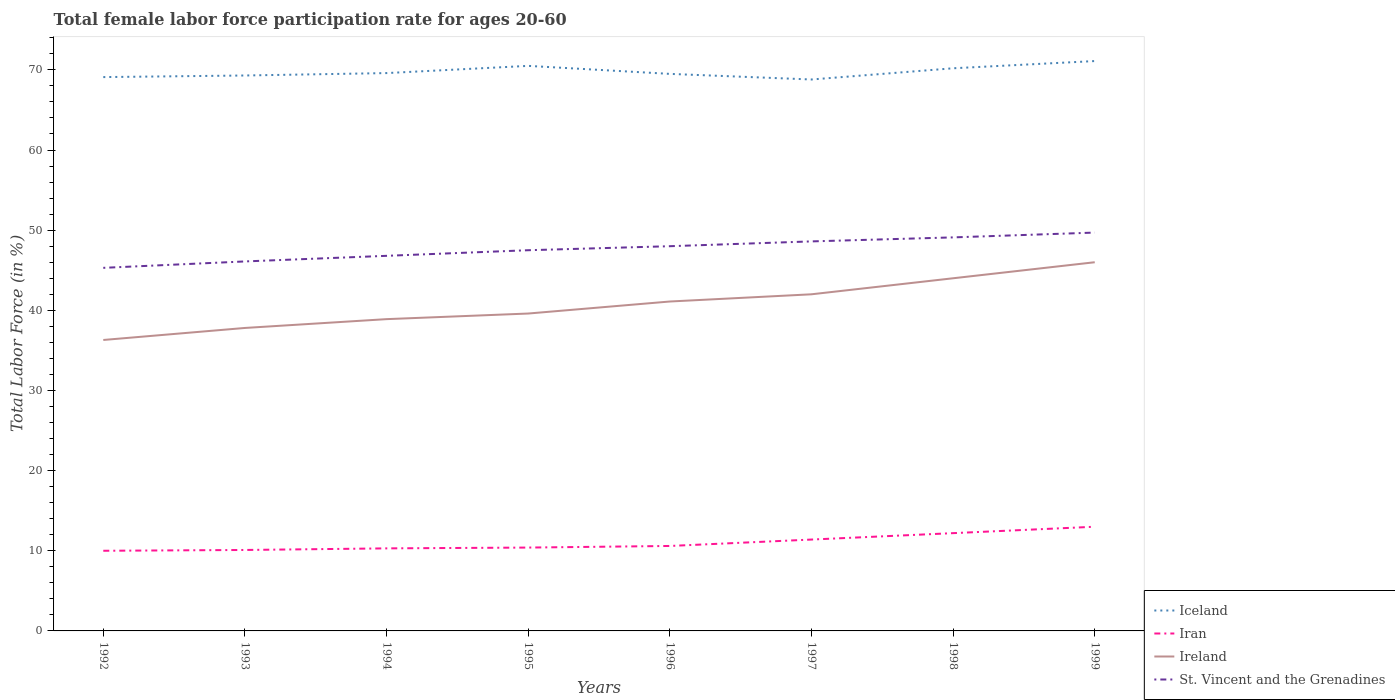Does the line corresponding to Iran intersect with the line corresponding to Ireland?
Offer a terse response. No. Is the number of lines equal to the number of legend labels?
Keep it short and to the point. Yes. Across all years, what is the maximum female labor force participation rate in Ireland?
Keep it short and to the point. 36.3. In which year was the female labor force participation rate in Iran maximum?
Offer a terse response. 1992. What is the total female labor force participation rate in St. Vincent and the Grenadines in the graph?
Ensure brevity in your answer.  -3.3. What is the difference between the highest and the second highest female labor force participation rate in Iran?
Give a very brief answer. 3. Is the female labor force participation rate in St. Vincent and the Grenadines strictly greater than the female labor force participation rate in Iceland over the years?
Provide a short and direct response. Yes. How many lines are there?
Provide a succinct answer. 4. What is the difference between two consecutive major ticks on the Y-axis?
Keep it short and to the point. 10. Are the values on the major ticks of Y-axis written in scientific E-notation?
Provide a succinct answer. No. Does the graph contain any zero values?
Your response must be concise. No. Does the graph contain grids?
Your response must be concise. No. How are the legend labels stacked?
Make the answer very short. Vertical. What is the title of the graph?
Provide a short and direct response. Total female labor force participation rate for ages 20-60. Does "St. Kitts and Nevis" appear as one of the legend labels in the graph?
Offer a very short reply. No. What is the Total Labor Force (in %) in Iceland in 1992?
Provide a succinct answer. 69.1. What is the Total Labor Force (in %) of Iran in 1992?
Offer a very short reply. 10. What is the Total Labor Force (in %) in Ireland in 1992?
Your response must be concise. 36.3. What is the Total Labor Force (in %) of St. Vincent and the Grenadines in 1992?
Provide a succinct answer. 45.3. What is the Total Labor Force (in %) in Iceland in 1993?
Make the answer very short. 69.3. What is the Total Labor Force (in %) in Iran in 1993?
Give a very brief answer. 10.1. What is the Total Labor Force (in %) in Ireland in 1993?
Keep it short and to the point. 37.8. What is the Total Labor Force (in %) in St. Vincent and the Grenadines in 1993?
Keep it short and to the point. 46.1. What is the Total Labor Force (in %) in Iceland in 1994?
Keep it short and to the point. 69.6. What is the Total Labor Force (in %) of Iran in 1994?
Your answer should be very brief. 10.3. What is the Total Labor Force (in %) of Ireland in 1994?
Ensure brevity in your answer.  38.9. What is the Total Labor Force (in %) of St. Vincent and the Grenadines in 1994?
Offer a very short reply. 46.8. What is the Total Labor Force (in %) of Iceland in 1995?
Give a very brief answer. 70.5. What is the Total Labor Force (in %) in Iran in 1995?
Ensure brevity in your answer.  10.4. What is the Total Labor Force (in %) in Ireland in 1995?
Provide a short and direct response. 39.6. What is the Total Labor Force (in %) of St. Vincent and the Grenadines in 1995?
Provide a succinct answer. 47.5. What is the Total Labor Force (in %) in Iceland in 1996?
Make the answer very short. 69.5. What is the Total Labor Force (in %) in Iran in 1996?
Provide a short and direct response. 10.6. What is the Total Labor Force (in %) of Ireland in 1996?
Give a very brief answer. 41.1. What is the Total Labor Force (in %) in Iceland in 1997?
Give a very brief answer. 68.8. What is the Total Labor Force (in %) of Iran in 1997?
Provide a short and direct response. 11.4. What is the Total Labor Force (in %) in St. Vincent and the Grenadines in 1997?
Keep it short and to the point. 48.6. What is the Total Labor Force (in %) of Iceland in 1998?
Provide a succinct answer. 70.2. What is the Total Labor Force (in %) in Iran in 1998?
Your answer should be very brief. 12.2. What is the Total Labor Force (in %) in Ireland in 1998?
Give a very brief answer. 44. What is the Total Labor Force (in %) in St. Vincent and the Grenadines in 1998?
Offer a terse response. 49.1. What is the Total Labor Force (in %) of Iceland in 1999?
Provide a succinct answer. 71.1. What is the Total Labor Force (in %) in St. Vincent and the Grenadines in 1999?
Offer a very short reply. 49.7. Across all years, what is the maximum Total Labor Force (in %) of Iceland?
Offer a very short reply. 71.1. Across all years, what is the maximum Total Labor Force (in %) in St. Vincent and the Grenadines?
Provide a short and direct response. 49.7. Across all years, what is the minimum Total Labor Force (in %) of Iceland?
Offer a very short reply. 68.8. Across all years, what is the minimum Total Labor Force (in %) in Ireland?
Offer a very short reply. 36.3. Across all years, what is the minimum Total Labor Force (in %) of St. Vincent and the Grenadines?
Your answer should be compact. 45.3. What is the total Total Labor Force (in %) of Iceland in the graph?
Ensure brevity in your answer.  558.1. What is the total Total Labor Force (in %) in Ireland in the graph?
Offer a terse response. 325.7. What is the total Total Labor Force (in %) in St. Vincent and the Grenadines in the graph?
Your answer should be very brief. 381.1. What is the difference between the Total Labor Force (in %) of Ireland in 1992 and that in 1993?
Your response must be concise. -1.5. What is the difference between the Total Labor Force (in %) in St. Vincent and the Grenadines in 1992 and that in 1993?
Provide a succinct answer. -0.8. What is the difference between the Total Labor Force (in %) of Iceland in 1992 and that in 1994?
Offer a very short reply. -0.5. What is the difference between the Total Labor Force (in %) in St. Vincent and the Grenadines in 1992 and that in 1994?
Your response must be concise. -1.5. What is the difference between the Total Labor Force (in %) of Iceland in 1992 and that in 1995?
Offer a terse response. -1.4. What is the difference between the Total Labor Force (in %) of Ireland in 1992 and that in 1995?
Make the answer very short. -3.3. What is the difference between the Total Labor Force (in %) in St. Vincent and the Grenadines in 1992 and that in 1995?
Provide a short and direct response. -2.2. What is the difference between the Total Labor Force (in %) of Iceland in 1992 and that in 1996?
Make the answer very short. -0.4. What is the difference between the Total Labor Force (in %) in Iran in 1992 and that in 1996?
Offer a very short reply. -0.6. What is the difference between the Total Labor Force (in %) of Ireland in 1992 and that in 1996?
Offer a terse response. -4.8. What is the difference between the Total Labor Force (in %) of Iceland in 1992 and that in 1997?
Make the answer very short. 0.3. What is the difference between the Total Labor Force (in %) in Iran in 1992 and that in 1997?
Keep it short and to the point. -1.4. What is the difference between the Total Labor Force (in %) in Ireland in 1992 and that in 1997?
Ensure brevity in your answer.  -5.7. What is the difference between the Total Labor Force (in %) in Iran in 1992 and that in 1999?
Offer a terse response. -3. What is the difference between the Total Labor Force (in %) of Iceland in 1993 and that in 1995?
Offer a very short reply. -1.2. What is the difference between the Total Labor Force (in %) in Iran in 1993 and that in 1995?
Your answer should be compact. -0.3. What is the difference between the Total Labor Force (in %) in Ireland in 1993 and that in 1995?
Provide a short and direct response. -1.8. What is the difference between the Total Labor Force (in %) of Iceland in 1993 and that in 1996?
Your answer should be compact. -0.2. What is the difference between the Total Labor Force (in %) of Iran in 1993 and that in 1996?
Your answer should be very brief. -0.5. What is the difference between the Total Labor Force (in %) of Iceland in 1993 and that in 1997?
Make the answer very short. 0.5. What is the difference between the Total Labor Force (in %) in Iran in 1993 and that in 1997?
Offer a very short reply. -1.3. What is the difference between the Total Labor Force (in %) of Ireland in 1993 and that in 1997?
Make the answer very short. -4.2. What is the difference between the Total Labor Force (in %) in St. Vincent and the Grenadines in 1993 and that in 1997?
Give a very brief answer. -2.5. What is the difference between the Total Labor Force (in %) in Iceland in 1993 and that in 1998?
Provide a short and direct response. -0.9. What is the difference between the Total Labor Force (in %) of Ireland in 1994 and that in 1995?
Your response must be concise. -0.7. What is the difference between the Total Labor Force (in %) of Iceland in 1994 and that in 1996?
Offer a very short reply. 0.1. What is the difference between the Total Labor Force (in %) of Ireland in 1994 and that in 1996?
Keep it short and to the point. -2.2. What is the difference between the Total Labor Force (in %) in Iran in 1994 and that in 1998?
Offer a terse response. -1.9. What is the difference between the Total Labor Force (in %) of Iceland in 1994 and that in 1999?
Make the answer very short. -1.5. What is the difference between the Total Labor Force (in %) of Iran in 1994 and that in 1999?
Make the answer very short. -2.7. What is the difference between the Total Labor Force (in %) of Ireland in 1994 and that in 1999?
Offer a very short reply. -7.1. What is the difference between the Total Labor Force (in %) in St. Vincent and the Grenadines in 1994 and that in 1999?
Offer a terse response. -2.9. What is the difference between the Total Labor Force (in %) in Iran in 1995 and that in 1996?
Provide a succinct answer. -0.2. What is the difference between the Total Labor Force (in %) of Iran in 1995 and that in 1997?
Make the answer very short. -1. What is the difference between the Total Labor Force (in %) of Ireland in 1995 and that in 1997?
Offer a very short reply. -2.4. What is the difference between the Total Labor Force (in %) in St. Vincent and the Grenadines in 1995 and that in 1997?
Your answer should be very brief. -1.1. What is the difference between the Total Labor Force (in %) in Iceland in 1995 and that in 1998?
Offer a very short reply. 0.3. What is the difference between the Total Labor Force (in %) of Iran in 1995 and that in 1998?
Your answer should be very brief. -1.8. What is the difference between the Total Labor Force (in %) in Ireland in 1995 and that in 1998?
Make the answer very short. -4.4. What is the difference between the Total Labor Force (in %) in St. Vincent and the Grenadines in 1995 and that in 1998?
Make the answer very short. -1.6. What is the difference between the Total Labor Force (in %) of Iran in 1995 and that in 1999?
Provide a short and direct response. -2.6. What is the difference between the Total Labor Force (in %) of Iran in 1996 and that in 1997?
Your answer should be very brief. -0.8. What is the difference between the Total Labor Force (in %) in Ireland in 1996 and that in 1997?
Offer a terse response. -0.9. What is the difference between the Total Labor Force (in %) of Iceland in 1996 and that in 1998?
Make the answer very short. -0.7. What is the difference between the Total Labor Force (in %) in Iran in 1996 and that in 1998?
Offer a very short reply. -1.6. What is the difference between the Total Labor Force (in %) in St. Vincent and the Grenadines in 1996 and that in 1998?
Provide a succinct answer. -1.1. What is the difference between the Total Labor Force (in %) of Ireland in 1996 and that in 1999?
Ensure brevity in your answer.  -4.9. What is the difference between the Total Labor Force (in %) in St. Vincent and the Grenadines in 1996 and that in 1999?
Make the answer very short. -1.7. What is the difference between the Total Labor Force (in %) of Iran in 1997 and that in 1998?
Keep it short and to the point. -0.8. What is the difference between the Total Labor Force (in %) in Ireland in 1997 and that in 1999?
Your answer should be compact. -4. What is the difference between the Total Labor Force (in %) in St. Vincent and the Grenadines in 1997 and that in 1999?
Your answer should be very brief. -1.1. What is the difference between the Total Labor Force (in %) in St. Vincent and the Grenadines in 1998 and that in 1999?
Provide a succinct answer. -0.6. What is the difference between the Total Labor Force (in %) of Iceland in 1992 and the Total Labor Force (in %) of Iran in 1993?
Keep it short and to the point. 59. What is the difference between the Total Labor Force (in %) of Iceland in 1992 and the Total Labor Force (in %) of Ireland in 1993?
Offer a very short reply. 31.3. What is the difference between the Total Labor Force (in %) in Iran in 1992 and the Total Labor Force (in %) in Ireland in 1993?
Provide a short and direct response. -27.8. What is the difference between the Total Labor Force (in %) in Iran in 1992 and the Total Labor Force (in %) in St. Vincent and the Grenadines in 1993?
Provide a short and direct response. -36.1. What is the difference between the Total Labor Force (in %) in Ireland in 1992 and the Total Labor Force (in %) in St. Vincent and the Grenadines in 1993?
Your answer should be very brief. -9.8. What is the difference between the Total Labor Force (in %) in Iceland in 1992 and the Total Labor Force (in %) in Iran in 1994?
Offer a terse response. 58.8. What is the difference between the Total Labor Force (in %) in Iceland in 1992 and the Total Labor Force (in %) in Ireland in 1994?
Your answer should be very brief. 30.2. What is the difference between the Total Labor Force (in %) of Iceland in 1992 and the Total Labor Force (in %) of St. Vincent and the Grenadines in 1994?
Offer a very short reply. 22.3. What is the difference between the Total Labor Force (in %) of Iran in 1992 and the Total Labor Force (in %) of Ireland in 1994?
Keep it short and to the point. -28.9. What is the difference between the Total Labor Force (in %) in Iran in 1992 and the Total Labor Force (in %) in St. Vincent and the Grenadines in 1994?
Make the answer very short. -36.8. What is the difference between the Total Labor Force (in %) of Ireland in 1992 and the Total Labor Force (in %) of St. Vincent and the Grenadines in 1994?
Ensure brevity in your answer.  -10.5. What is the difference between the Total Labor Force (in %) of Iceland in 1992 and the Total Labor Force (in %) of Iran in 1995?
Make the answer very short. 58.7. What is the difference between the Total Labor Force (in %) of Iceland in 1992 and the Total Labor Force (in %) of Ireland in 1995?
Offer a terse response. 29.5. What is the difference between the Total Labor Force (in %) in Iceland in 1992 and the Total Labor Force (in %) in St. Vincent and the Grenadines in 1995?
Your answer should be very brief. 21.6. What is the difference between the Total Labor Force (in %) in Iran in 1992 and the Total Labor Force (in %) in Ireland in 1995?
Keep it short and to the point. -29.6. What is the difference between the Total Labor Force (in %) of Iran in 1992 and the Total Labor Force (in %) of St. Vincent and the Grenadines in 1995?
Provide a short and direct response. -37.5. What is the difference between the Total Labor Force (in %) in Iceland in 1992 and the Total Labor Force (in %) in Iran in 1996?
Your answer should be very brief. 58.5. What is the difference between the Total Labor Force (in %) in Iceland in 1992 and the Total Labor Force (in %) in Ireland in 1996?
Your answer should be very brief. 28. What is the difference between the Total Labor Force (in %) in Iceland in 1992 and the Total Labor Force (in %) in St. Vincent and the Grenadines in 1996?
Give a very brief answer. 21.1. What is the difference between the Total Labor Force (in %) of Iran in 1992 and the Total Labor Force (in %) of Ireland in 1996?
Your answer should be very brief. -31.1. What is the difference between the Total Labor Force (in %) in Iran in 1992 and the Total Labor Force (in %) in St. Vincent and the Grenadines in 1996?
Provide a succinct answer. -38. What is the difference between the Total Labor Force (in %) of Ireland in 1992 and the Total Labor Force (in %) of St. Vincent and the Grenadines in 1996?
Ensure brevity in your answer.  -11.7. What is the difference between the Total Labor Force (in %) of Iceland in 1992 and the Total Labor Force (in %) of Iran in 1997?
Give a very brief answer. 57.7. What is the difference between the Total Labor Force (in %) in Iceland in 1992 and the Total Labor Force (in %) in Ireland in 1997?
Offer a terse response. 27.1. What is the difference between the Total Labor Force (in %) of Iran in 1992 and the Total Labor Force (in %) of Ireland in 1997?
Keep it short and to the point. -32. What is the difference between the Total Labor Force (in %) of Iran in 1992 and the Total Labor Force (in %) of St. Vincent and the Grenadines in 1997?
Provide a short and direct response. -38.6. What is the difference between the Total Labor Force (in %) in Ireland in 1992 and the Total Labor Force (in %) in St. Vincent and the Grenadines in 1997?
Provide a short and direct response. -12.3. What is the difference between the Total Labor Force (in %) of Iceland in 1992 and the Total Labor Force (in %) of Iran in 1998?
Offer a very short reply. 56.9. What is the difference between the Total Labor Force (in %) in Iceland in 1992 and the Total Labor Force (in %) in Ireland in 1998?
Offer a terse response. 25.1. What is the difference between the Total Labor Force (in %) in Iran in 1992 and the Total Labor Force (in %) in Ireland in 1998?
Provide a succinct answer. -34. What is the difference between the Total Labor Force (in %) of Iran in 1992 and the Total Labor Force (in %) of St. Vincent and the Grenadines in 1998?
Make the answer very short. -39.1. What is the difference between the Total Labor Force (in %) in Iceland in 1992 and the Total Labor Force (in %) in Iran in 1999?
Provide a succinct answer. 56.1. What is the difference between the Total Labor Force (in %) of Iceland in 1992 and the Total Labor Force (in %) of Ireland in 1999?
Offer a terse response. 23.1. What is the difference between the Total Labor Force (in %) in Iceland in 1992 and the Total Labor Force (in %) in St. Vincent and the Grenadines in 1999?
Ensure brevity in your answer.  19.4. What is the difference between the Total Labor Force (in %) in Iran in 1992 and the Total Labor Force (in %) in Ireland in 1999?
Your response must be concise. -36. What is the difference between the Total Labor Force (in %) in Iran in 1992 and the Total Labor Force (in %) in St. Vincent and the Grenadines in 1999?
Make the answer very short. -39.7. What is the difference between the Total Labor Force (in %) of Ireland in 1992 and the Total Labor Force (in %) of St. Vincent and the Grenadines in 1999?
Offer a terse response. -13.4. What is the difference between the Total Labor Force (in %) of Iceland in 1993 and the Total Labor Force (in %) of Ireland in 1994?
Offer a terse response. 30.4. What is the difference between the Total Labor Force (in %) in Iceland in 1993 and the Total Labor Force (in %) in St. Vincent and the Grenadines in 1994?
Ensure brevity in your answer.  22.5. What is the difference between the Total Labor Force (in %) of Iran in 1993 and the Total Labor Force (in %) of Ireland in 1994?
Provide a short and direct response. -28.8. What is the difference between the Total Labor Force (in %) of Iran in 1993 and the Total Labor Force (in %) of St. Vincent and the Grenadines in 1994?
Your answer should be very brief. -36.7. What is the difference between the Total Labor Force (in %) in Iceland in 1993 and the Total Labor Force (in %) in Iran in 1995?
Offer a terse response. 58.9. What is the difference between the Total Labor Force (in %) of Iceland in 1993 and the Total Labor Force (in %) of Ireland in 1995?
Your answer should be compact. 29.7. What is the difference between the Total Labor Force (in %) of Iceland in 1993 and the Total Labor Force (in %) of St. Vincent and the Grenadines in 1995?
Give a very brief answer. 21.8. What is the difference between the Total Labor Force (in %) of Iran in 1993 and the Total Labor Force (in %) of Ireland in 1995?
Make the answer very short. -29.5. What is the difference between the Total Labor Force (in %) of Iran in 1993 and the Total Labor Force (in %) of St. Vincent and the Grenadines in 1995?
Your answer should be very brief. -37.4. What is the difference between the Total Labor Force (in %) of Iceland in 1993 and the Total Labor Force (in %) of Iran in 1996?
Your answer should be compact. 58.7. What is the difference between the Total Labor Force (in %) of Iceland in 1993 and the Total Labor Force (in %) of Ireland in 1996?
Provide a short and direct response. 28.2. What is the difference between the Total Labor Force (in %) in Iceland in 1993 and the Total Labor Force (in %) in St. Vincent and the Grenadines in 1996?
Offer a terse response. 21.3. What is the difference between the Total Labor Force (in %) of Iran in 1993 and the Total Labor Force (in %) of Ireland in 1996?
Offer a terse response. -31. What is the difference between the Total Labor Force (in %) in Iran in 1993 and the Total Labor Force (in %) in St. Vincent and the Grenadines in 1996?
Ensure brevity in your answer.  -37.9. What is the difference between the Total Labor Force (in %) of Iceland in 1993 and the Total Labor Force (in %) of Iran in 1997?
Make the answer very short. 57.9. What is the difference between the Total Labor Force (in %) of Iceland in 1993 and the Total Labor Force (in %) of Ireland in 1997?
Your answer should be very brief. 27.3. What is the difference between the Total Labor Force (in %) in Iceland in 1993 and the Total Labor Force (in %) in St. Vincent and the Grenadines in 1997?
Your answer should be very brief. 20.7. What is the difference between the Total Labor Force (in %) in Iran in 1993 and the Total Labor Force (in %) in Ireland in 1997?
Provide a succinct answer. -31.9. What is the difference between the Total Labor Force (in %) in Iran in 1993 and the Total Labor Force (in %) in St. Vincent and the Grenadines in 1997?
Your answer should be very brief. -38.5. What is the difference between the Total Labor Force (in %) in Ireland in 1993 and the Total Labor Force (in %) in St. Vincent and the Grenadines in 1997?
Give a very brief answer. -10.8. What is the difference between the Total Labor Force (in %) in Iceland in 1993 and the Total Labor Force (in %) in Iran in 1998?
Your answer should be compact. 57.1. What is the difference between the Total Labor Force (in %) in Iceland in 1993 and the Total Labor Force (in %) in Ireland in 1998?
Ensure brevity in your answer.  25.3. What is the difference between the Total Labor Force (in %) in Iceland in 1993 and the Total Labor Force (in %) in St. Vincent and the Grenadines in 1998?
Your answer should be compact. 20.2. What is the difference between the Total Labor Force (in %) in Iran in 1993 and the Total Labor Force (in %) in Ireland in 1998?
Ensure brevity in your answer.  -33.9. What is the difference between the Total Labor Force (in %) in Iran in 1993 and the Total Labor Force (in %) in St. Vincent and the Grenadines in 1998?
Provide a short and direct response. -39. What is the difference between the Total Labor Force (in %) of Iceland in 1993 and the Total Labor Force (in %) of Iran in 1999?
Give a very brief answer. 56.3. What is the difference between the Total Labor Force (in %) of Iceland in 1993 and the Total Labor Force (in %) of Ireland in 1999?
Provide a succinct answer. 23.3. What is the difference between the Total Labor Force (in %) of Iceland in 1993 and the Total Labor Force (in %) of St. Vincent and the Grenadines in 1999?
Keep it short and to the point. 19.6. What is the difference between the Total Labor Force (in %) in Iran in 1993 and the Total Labor Force (in %) in Ireland in 1999?
Offer a terse response. -35.9. What is the difference between the Total Labor Force (in %) of Iran in 1993 and the Total Labor Force (in %) of St. Vincent and the Grenadines in 1999?
Offer a very short reply. -39.6. What is the difference between the Total Labor Force (in %) in Iceland in 1994 and the Total Labor Force (in %) in Iran in 1995?
Ensure brevity in your answer.  59.2. What is the difference between the Total Labor Force (in %) in Iceland in 1994 and the Total Labor Force (in %) in Ireland in 1995?
Provide a short and direct response. 30. What is the difference between the Total Labor Force (in %) in Iceland in 1994 and the Total Labor Force (in %) in St. Vincent and the Grenadines in 1995?
Keep it short and to the point. 22.1. What is the difference between the Total Labor Force (in %) of Iran in 1994 and the Total Labor Force (in %) of Ireland in 1995?
Keep it short and to the point. -29.3. What is the difference between the Total Labor Force (in %) in Iran in 1994 and the Total Labor Force (in %) in St. Vincent and the Grenadines in 1995?
Keep it short and to the point. -37.2. What is the difference between the Total Labor Force (in %) in Ireland in 1994 and the Total Labor Force (in %) in St. Vincent and the Grenadines in 1995?
Keep it short and to the point. -8.6. What is the difference between the Total Labor Force (in %) of Iceland in 1994 and the Total Labor Force (in %) of Iran in 1996?
Offer a very short reply. 59. What is the difference between the Total Labor Force (in %) in Iceland in 1994 and the Total Labor Force (in %) in St. Vincent and the Grenadines in 1996?
Your response must be concise. 21.6. What is the difference between the Total Labor Force (in %) of Iran in 1994 and the Total Labor Force (in %) of Ireland in 1996?
Give a very brief answer. -30.8. What is the difference between the Total Labor Force (in %) of Iran in 1994 and the Total Labor Force (in %) of St. Vincent and the Grenadines in 1996?
Provide a short and direct response. -37.7. What is the difference between the Total Labor Force (in %) of Ireland in 1994 and the Total Labor Force (in %) of St. Vincent and the Grenadines in 1996?
Your answer should be very brief. -9.1. What is the difference between the Total Labor Force (in %) of Iceland in 1994 and the Total Labor Force (in %) of Iran in 1997?
Your answer should be very brief. 58.2. What is the difference between the Total Labor Force (in %) in Iceland in 1994 and the Total Labor Force (in %) in Ireland in 1997?
Your response must be concise. 27.6. What is the difference between the Total Labor Force (in %) in Iceland in 1994 and the Total Labor Force (in %) in St. Vincent and the Grenadines in 1997?
Ensure brevity in your answer.  21. What is the difference between the Total Labor Force (in %) of Iran in 1994 and the Total Labor Force (in %) of Ireland in 1997?
Your answer should be very brief. -31.7. What is the difference between the Total Labor Force (in %) of Iran in 1994 and the Total Labor Force (in %) of St. Vincent and the Grenadines in 1997?
Give a very brief answer. -38.3. What is the difference between the Total Labor Force (in %) in Iceland in 1994 and the Total Labor Force (in %) in Iran in 1998?
Provide a succinct answer. 57.4. What is the difference between the Total Labor Force (in %) in Iceland in 1994 and the Total Labor Force (in %) in Ireland in 1998?
Offer a terse response. 25.6. What is the difference between the Total Labor Force (in %) in Iceland in 1994 and the Total Labor Force (in %) in St. Vincent and the Grenadines in 1998?
Your answer should be compact. 20.5. What is the difference between the Total Labor Force (in %) in Iran in 1994 and the Total Labor Force (in %) in Ireland in 1998?
Offer a terse response. -33.7. What is the difference between the Total Labor Force (in %) in Iran in 1994 and the Total Labor Force (in %) in St. Vincent and the Grenadines in 1998?
Your answer should be compact. -38.8. What is the difference between the Total Labor Force (in %) of Iceland in 1994 and the Total Labor Force (in %) of Iran in 1999?
Offer a terse response. 56.6. What is the difference between the Total Labor Force (in %) in Iceland in 1994 and the Total Labor Force (in %) in Ireland in 1999?
Your answer should be very brief. 23.6. What is the difference between the Total Labor Force (in %) in Iceland in 1994 and the Total Labor Force (in %) in St. Vincent and the Grenadines in 1999?
Offer a very short reply. 19.9. What is the difference between the Total Labor Force (in %) of Iran in 1994 and the Total Labor Force (in %) of Ireland in 1999?
Offer a very short reply. -35.7. What is the difference between the Total Labor Force (in %) in Iran in 1994 and the Total Labor Force (in %) in St. Vincent and the Grenadines in 1999?
Keep it short and to the point. -39.4. What is the difference between the Total Labor Force (in %) in Iceland in 1995 and the Total Labor Force (in %) in Iran in 1996?
Provide a short and direct response. 59.9. What is the difference between the Total Labor Force (in %) in Iceland in 1995 and the Total Labor Force (in %) in Ireland in 1996?
Offer a terse response. 29.4. What is the difference between the Total Labor Force (in %) in Iran in 1995 and the Total Labor Force (in %) in Ireland in 1996?
Your response must be concise. -30.7. What is the difference between the Total Labor Force (in %) in Iran in 1995 and the Total Labor Force (in %) in St. Vincent and the Grenadines in 1996?
Your answer should be very brief. -37.6. What is the difference between the Total Labor Force (in %) in Iceland in 1995 and the Total Labor Force (in %) in Iran in 1997?
Your response must be concise. 59.1. What is the difference between the Total Labor Force (in %) of Iceland in 1995 and the Total Labor Force (in %) of St. Vincent and the Grenadines in 1997?
Offer a terse response. 21.9. What is the difference between the Total Labor Force (in %) of Iran in 1995 and the Total Labor Force (in %) of Ireland in 1997?
Provide a succinct answer. -31.6. What is the difference between the Total Labor Force (in %) of Iran in 1995 and the Total Labor Force (in %) of St. Vincent and the Grenadines in 1997?
Offer a very short reply. -38.2. What is the difference between the Total Labor Force (in %) of Iceland in 1995 and the Total Labor Force (in %) of Iran in 1998?
Your answer should be compact. 58.3. What is the difference between the Total Labor Force (in %) of Iceland in 1995 and the Total Labor Force (in %) of St. Vincent and the Grenadines in 1998?
Ensure brevity in your answer.  21.4. What is the difference between the Total Labor Force (in %) of Iran in 1995 and the Total Labor Force (in %) of Ireland in 1998?
Provide a short and direct response. -33.6. What is the difference between the Total Labor Force (in %) of Iran in 1995 and the Total Labor Force (in %) of St. Vincent and the Grenadines in 1998?
Your response must be concise. -38.7. What is the difference between the Total Labor Force (in %) in Ireland in 1995 and the Total Labor Force (in %) in St. Vincent and the Grenadines in 1998?
Make the answer very short. -9.5. What is the difference between the Total Labor Force (in %) of Iceland in 1995 and the Total Labor Force (in %) of Iran in 1999?
Ensure brevity in your answer.  57.5. What is the difference between the Total Labor Force (in %) in Iceland in 1995 and the Total Labor Force (in %) in Ireland in 1999?
Keep it short and to the point. 24.5. What is the difference between the Total Labor Force (in %) in Iceland in 1995 and the Total Labor Force (in %) in St. Vincent and the Grenadines in 1999?
Provide a succinct answer. 20.8. What is the difference between the Total Labor Force (in %) in Iran in 1995 and the Total Labor Force (in %) in Ireland in 1999?
Your answer should be very brief. -35.6. What is the difference between the Total Labor Force (in %) of Iran in 1995 and the Total Labor Force (in %) of St. Vincent and the Grenadines in 1999?
Offer a terse response. -39.3. What is the difference between the Total Labor Force (in %) of Iceland in 1996 and the Total Labor Force (in %) of Iran in 1997?
Provide a short and direct response. 58.1. What is the difference between the Total Labor Force (in %) of Iceland in 1996 and the Total Labor Force (in %) of Ireland in 1997?
Your answer should be compact. 27.5. What is the difference between the Total Labor Force (in %) of Iceland in 1996 and the Total Labor Force (in %) of St. Vincent and the Grenadines in 1997?
Keep it short and to the point. 20.9. What is the difference between the Total Labor Force (in %) in Iran in 1996 and the Total Labor Force (in %) in Ireland in 1997?
Offer a very short reply. -31.4. What is the difference between the Total Labor Force (in %) in Iran in 1996 and the Total Labor Force (in %) in St. Vincent and the Grenadines in 1997?
Provide a short and direct response. -38. What is the difference between the Total Labor Force (in %) in Ireland in 1996 and the Total Labor Force (in %) in St. Vincent and the Grenadines in 1997?
Give a very brief answer. -7.5. What is the difference between the Total Labor Force (in %) of Iceland in 1996 and the Total Labor Force (in %) of Iran in 1998?
Keep it short and to the point. 57.3. What is the difference between the Total Labor Force (in %) in Iceland in 1996 and the Total Labor Force (in %) in St. Vincent and the Grenadines in 1998?
Offer a terse response. 20.4. What is the difference between the Total Labor Force (in %) in Iran in 1996 and the Total Labor Force (in %) in Ireland in 1998?
Offer a terse response. -33.4. What is the difference between the Total Labor Force (in %) in Iran in 1996 and the Total Labor Force (in %) in St. Vincent and the Grenadines in 1998?
Provide a succinct answer. -38.5. What is the difference between the Total Labor Force (in %) in Ireland in 1996 and the Total Labor Force (in %) in St. Vincent and the Grenadines in 1998?
Make the answer very short. -8. What is the difference between the Total Labor Force (in %) in Iceland in 1996 and the Total Labor Force (in %) in Iran in 1999?
Keep it short and to the point. 56.5. What is the difference between the Total Labor Force (in %) of Iceland in 1996 and the Total Labor Force (in %) of Ireland in 1999?
Offer a terse response. 23.5. What is the difference between the Total Labor Force (in %) of Iceland in 1996 and the Total Labor Force (in %) of St. Vincent and the Grenadines in 1999?
Your answer should be very brief. 19.8. What is the difference between the Total Labor Force (in %) in Iran in 1996 and the Total Labor Force (in %) in Ireland in 1999?
Keep it short and to the point. -35.4. What is the difference between the Total Labor Force (in %) in Iran in 1996 and the Total Labor Force (in %) in St. Vincent and the Grenadines in 1999?
Provide a succinct answer. -39.1. What is the difference between the Total Labor Force (in %) in Ireland in 1996 and the Total Labor Force (in %) in St. Vincent and the Grenadines in 1999?
Your response must be concise. -8.6. What is the difference between the Total Labor Force (in %) in Iceland in 1997 and the Total Labor Force (in %) in Iran in 1998?
Your response must be concise. 56.6. What is the difference between the Total Labor Force (in %) of Iceland in 1997 and the Total Labor Force (in %) of Ireland in 1998?
Offer a very short reply. 24.8. What is the difference between the Total Labor Force (in %) of Iran in 1997 and the Total Labor Force (in %) of Ireland in 1998?
Provide a succinct answer. -32.6. What is the difference between the Total Labor Force (in %) in Iran in 1997 and the Total Labor Force (in %) in St. Vincent and the Grenadines in 1998?
Make the answer very short. -37.7. What is the difference between the Total Labor Force (in %) in Ireland in 1997 and the Total Labor Force (in %) in St. Vincent and the Grenadines in 1998?
Ensure brevity in your answer.  -7.1. What is the difference between the Total Labor Force (in %) of Iceland in 1997 and the Total Labor Force (in %) of Iran in 1999?
Provide a succinct answer. 55.8. What is the difference between the Total Labor Force (in %) of Iceland in 1997 and the Total Labor Force (in %) of Ireland in 1999?
Offer a very short reply. 22.8. What is the difference between the Total Labor Force (in %) in Iceland in 1997 and the Total Labor Force (in %) in St. Vincent and the Grenadines in 1999?
Offer a terse response. 19.1. What is the difference between the Total Labor Force (in %) in Iran in 1997 and the Total Labor Force (in %) in Ireland in 1999?
Make the answer very short. -34.6. What is the difference between the Total Labor Force (in %) of Iran in 1997 and the Total Labor Force (in %) of St. Vincent and the Grenadines in 1999?
Your answer should be very brief. -38.3. What is the difference between the Total Labor Force (in %) in Iceland in 1998 and the Total Labor Force (in %) in Iran in 1999?
Offer a very short reply. 57.2. What is the difference between the Total Labor Force (in %) of Iceland in 1998 and the Total Labor Force (in %) of Ireland in 1999?
Make the answer very short. 24.2. What is the difference between the Total Labor Force (in %) in Iceland in 1998 and the Total Labor Force (in %) in St. Vincent and the Grenadines in 1999?
Offer a terse response. 20.5. What is the difference between the Total Labor Force (in %) in Iran in 1998 and the Total Labor Force (in %) in Ireland in 1999?
Your response must be concise. -33.8. What is the difference between the Total Labor Force (in %) in Iran in 1998 and the Total Labor Force (in %) in St. Vincent and the Grenadines in 1999?
Give a very brief answer. -37.5. What is the average Total Labor Force (in %) in Iceland per year?
Give a very brief answer. 69.76. What is the average Total Labor Force (in %) in Iran per year?
Your answer should be compact. 11. What is the average Total Labor Force (in %) in Ireland per year?
Keep it short and to the point. 40.71. What is the average Total Labor Force (in %) in St. Vincent and the Grenadines per year?
Ensure brevity in your answer.  47.64. In the year 1992, what is the difference between the Total Labor Force (in %) in Iceland and Total Labor Force (in %) in Iran?
Your answer should be compact. 59.1. In the year 1992, what is the difference between the Total Labor Force (in %) in Iceland and Total Labor Force (in %) in Ireland?
Offer a very short reply. 32.8. In the year 1992, what is the difference between the Total Labor Force (in %) of Iceland and Total Labor Force (in %) of St. Vincent and the Grenadines?
Provide a succinct answer. 23.8. In the year 1992, what is the difference between the Total Labor Force (in %) of Iran and Total Labor Force (in %) of Ireland?
Ensure brevity in your answer.  -26.3. In the year 1992, what is the difference between the Total Labor Force (in %) of Iran and Total Labor Force (in %) of St. Vincent and the Grenadines?
Offer a very short reply. -35.3. In the year 1992, what is the difference between the Total Labor Force (in %) of Ireland and Total Labor Force (in %) of St. Vincent and the Grenadines?
Keep it short and to the point. -9. In the year 1993, what is the difference between the Total Labor Force (in %) of Iceland and Total Labor Force (in %) of Iran?
Offer a very short reply. 59.2. In the year 1993, what is the difference between the Total Labor Force (in %) in Iceland and Total Labor Force (in %) in Ireland?
Offer a terse response. 31.5. In the year 1993, what is the difference between the Total Labor Force (in %) in Iceland and Total Labor Force (in %) in St. Vincent and the Grenadines?
Offer a terse response. 23.2. In the year 1993, what is the difference between the Total Labor Force (in %) in Iran and Total Labor Force (in %) in Ireland?
Ensure brevity in your answer.  -27.7. In the year 1993, what is the difference between the Total Labor Force (in %) of Iran and Total Labor Force (in %) of St. Vincent and the Grenadines?
Make the answer very short. -36. In the year 1993, what is the difference between the Total Labor Force (in %) in Ireland and Total Labor Force (in %) in St. Vincent and the Grenadines?
Your answer should be very brief. -8.3. In the year 1994, what is the difference between the Total Labor Force (in %) of Iceland and Total Labor Force (in %) of Iran?
Offer a terse response. 59.3. In the year 1994, what is the difference between the Total Labor Force (in %) of Iceland and Total Labor Force (in %) of Ireland?
Your answer should be very brief. 30.7. In the year 1994, what is the difference between the Total Labor Force (in %) in Iceland and Total Labor Force (in %) in St. Vincent and the Grenadines?
Your response must be concise. 22.8. In the year 1994, what is the difference between the Total Labor Force (in %) in Iran and Total Labor Force (in %) in Ireland?
Offer a terse response. -28.6. In the year 1994, what is the difference between the Total Labor Force (in %) in Iran and Total Labor Force (in %) in St. Vincent and the Grenadines?
Provide a short and direct response. -36.5. In the year 1994, what is the difference between the Total Labor Force (in %) of Ireland and Total Labor Force (in %) of St. Vincent and the Grenadines?
Your response must be concise. -7.9. In the year 1995, what is the difference between the Total Labor Force (in %) in Iceland and Total Labor Force (in %) in Iran?
Ensure brevity in your answer.  60.1. In the year 1995, what is the difference between the Total Labor Force (in %) in Iceland and Total Labor Force (in %) in Ireland?
Your response must be concise. 30.9. In the year 1995, what is the difference between the Total Labor Force (in %) in Iran and Total Labor Force (in %) in Ireland?
Make the answer very short. -29.2. In the year 1995, what is the difference between the Total Labor Force (in %) in Iran and Total Labor Force (in %) in St. Vincent and the Grenadines?
Your answer should be compact. -37.1. In the year 1996, what is the difference between the Total Labor Force (in %) in Iceland and Total Labor Force (in %) in Iran?
Offer a terse response. 58.9. In the year 1996, what is the difference between the Total Labor Force (in %) in Iceland and Total Labor Force (in %) in Ireland?
Offer a very short reply. 28.4. In the year 1996, what is the difference between the Total Labor Force (in %) in Iceland and Total Labor Force (in %) in St. Vincent and the Grenadines?
Your answer should be compact. 21.5. In the year 1996, what is the difference between the Total Labor Force (in %) of Iran and Total Labor Force (in %) of Ireland?
Offer a very short reply. -30.5. In the year 1996, what is the difference between the Total Labor Force (in %) in Iran and Total Labor Force (in %) in St. Vincent and the Grenadines?
Offer a very short reply. -37.4. In the year 1996, what is the difference between the Total Labor Force (in %) of Ireland and Total Labor Force (in %) of St. Vincent and the Grenadines?
Your answer should be very brief. -6.9. In the year 1997, what is the difference between the Total Labor Force (in %) in Iceland and Total Labor Force (in %) in Iran?
Your answer should be compact. 57.4. In the year 1997, what is the difference between the Total Labor Force (in %) of Iceland and Total Labor Force (in %) of Ireland?
Give a very brief answer. 26.8. In the year 1997, what is the difference between the Total Labor Force (in %) of Iceland and Total Labor Force (in %) of St. Vincent and the Grenadines?
Give a very brief answer. 20.2. In the year 1997, what is the difference between the Total Labor Force (in %) in Iran and Total Labor Force (in %) in Ireland?
Provide a short and direct response. -30.6. In the year 1997, what is the difference between the Total Labor Force (in %) in Iran and Total Labor Force (in %) in St. Vincent and the Grenadines?
Ensure brevity in your answer.  -37.2. In the year 1997, what is the difference between the Total Labor Force (in %) in Ireland and Total Labor Force (in %) in St. Vincent and the Grenadines?
Give a very brief answer. -6.6. In the year 1998, what is the difference between the Total Labor Force (in %) of Iceland and Total Labor Force (in %) of Iran?
Offer a terse response. 58. In the year 1998, what is the difference between the Total Labor Force (in %) in Iceland and Total Labor Force (in %) in Ireland?
Keep it short and to the point. 26.2. In the year 1998, what is the difference between the Total Labor Force (in %) in Iceland and Total Labor Force (in %) in St. Vincent and the Grenadines?
Provide a short and direct response. 21.1. In the year 1998, what is the difference between the Total Labor Force (in %) in Iran and Total Labor Force (in %) in Ireland?
Make the answer very short. -31.8. In the year 1998, what is the difference between the Total Labor Force (in %) of Iran and Total Labor Force (in %) of St. Vincent and the Grenadines?
Offer a terse response. -36.9. In the year 1998, what is the difference between the Total Labor Force (in %) of Ireland and Total Labor Force (in %) of St. Vincent and the Grenadines?
Provide a short and direct response. -5.1. In the year 1999, what is the difference between the Total Labor Force (in %) of Iceland and Total Labor Force (in %) of Iran?
Make the answer very short. 58.1. In the year 1999, what is the difference between the Total Labor Force (in %) in Iceland and Total Labor Force (in %) in Ireland?
Ensure brevity in your answer.  25.1. In the year 1999, what is the difference between the Total Labor Force (in %) of Iceland and Total Labor Force (in %) of St. Vincent and the Grenadines?
Keep it short and to the point. 21.4. In the year 1999, what is the difference between the Total Labor Force (in %) in Iran and Total Labor Force (in %) in Ireland?
Offer a very short reply. -33. In the year 1999, what is the difference between the Total Labor Force (in %) in Iran and Total Labor Force (in %) in St. Vincent and the Grenadines?
Your answer should be very brief. -36.7. What is the ratio of the Total Labor Force (in %) of Iceland in 1992 to that in 1993?
Offer a terse response. 1. What is the ratio of the Total Labor Force (in %) in Ireland in 1992 to that in 1993?
Your response must be concise. 0.96. What is the ratio of the Total Labor Force (in %) of St. Vincent and the Grenadines in 1992 to that in 1993?
Your answer should be compact. 0.98. What is the ratio of the Total Labor Force (in %) of Iceland in 1992 to that in 1994?
Provide a short and direct response. 0.99. What is the ratio of the Total Labor Force (in %) of Iran in 1992 to that in 1994?
Your response must be concise. 0.97. What is the ratio of the Total Labor Force (in %) in Ireland in 1992 to that in 1994?
Make the answer very short. 0.93. What is the ratio of the Total Labor Force (in %) of St. Vincent and the Grenadines in 1992 to that in 1994?
Your answer should be compact. 0.97. What is the ratio of the Total Labor Force (in %) in Iceland in 1992 to that in 1995?
Provide a short and direct response. 0.98. What is the ratio of the Total Labor Force (in %) of Iran in 1992 to that in 1995?
Your response must be concise. 0.96. What is the ratio of the Total Labor Force (in %) in St. Vincent and the Grenadines in 1992 to that in 1995?
Make the answer very short. 0.95. What is the ratio of the Total Labor Force (in %) in Iran in 1992 to that in 1996?
Offer a terse response. 0.94. What is the ratio of the Total Labor Force (in %) of Ireland in 1992 to that in 1996?
Ensure brevity in your answer.  0.88. What is the ratio of the Total Labor Force (in %) in St. Vincent and the Grenadines in 1992 to that in 1996?
Provide a succinct answer. 0.94. What is the ratio of the Total Labor Force (in %) of Iceland in 1992 to that in 1997?
Ensure brevity in your answer.  1. What is the ratio of the Total Labor Force (in %) of Iran in 1992 to that in 1997?
Give a very brief answer. 0.88. What is the ratio of the Total Labor Force (in %) of Ireland in 1992 to that in 1997?
Your answer should be very brief. 0.86. What is the ratio of the Total Labor Force (in %) of St. Vincent and the Grenadines in 1992 to that in 1997?
Offer a very short reply. 0.93. What is the ratio of the Total Labor Force (in %) in Iceland in 1992 to that in 1998?
Keep it short and to the point. 0.98. What is the ratio of the Total Labor Force (in %) of Iran in 1992 to that in 1998?
Offer a terse response. 0.82. What is the ratio of the Total Labor Force (in %) of Ireland in 1992 to that in 1998?
Make the answer very short. 0.82. What is the ratio of the Total Labor Force (in %) of St. Vincent and the Grenadines in 1992 to that in 1998?
Give a very brief answer. 0.92. What is the ratio of the Total Labor Force (in %) in Iceland in 1992 to that in 1999?
Your answer should be compact. 0.97. What is the ratio of the Total Labor Force (in %) of Iran in 1992 to that in 1999?
Provide a succinct answer. 0.77. What is the ratio of the Total Labor Force (in %) in Ireland in 1992 to that in 1999?
Your answer should be very brief. 0.79. What is the ratio of the Total Labor Force (in %) of St. Vincent and the Grenadines in 1992 to that in 1999?
Your answer should be very brief. 0.91. What is the ratio of the Total Labor Force (in %) in Iceland in 1993 to that in 1994?
Make the answer very short. 1. What is the ratio of the Total Labor Force (in %) in Iran in 1993 to that in 1994?
Give a very brief answer. 0.98. What is the ratio of the Total Labor Force (in %) in Ireland in 1993 to that in 1994?
Your answer should be very brief. 0.97. What is the ratio of the Total Labor Force (in %) in St. Vincent and the Grenadines in 1993 to that in 1994?
Make the answer very short. 0.98. What is the ratio of the Total Labor Force (in %) of Iceland in 1993 to that in 1995?
Your answer should be very brief. 0.98. What is the ratio of the Total Labor Force (in %) in Iran in 1993 to that in 1995?
Ensure brevity in your answer.  0.97. What is the ratio of the Total Labor Force (in %) of Ireland in 1993 to that in 1995?
Make the answer very short. 0.95. What is the ratio of the Total Labor Force (in %) in St. Vincent and the Grenadines in 1993 to that in 1995?
Make the answer very short. 0.97. What is the ratio of the Total Labor Force (in %) of Iceland in 1993 to that in 1996?
Give a very brief answer. 1. What is the ratio of the Total Labor Force (in %) of Iran in 1993 to that in 1996?
Provide a succinct answer. 0.95. What is the ratio of the Total Labor Force (in %) in Ireland in 1993 to that in 1996?
Provide a succinct answer. 0.92. What is the ratio of the Total Labor Force (in %) in St. Vincent and the Grenadines in 1993 to that in 1996?
Ensure brevity in your answer.  0.96. What is the ratio of the Total Labor Force (in %) in Iceland in 1993 to that in 1997?
Your answer should be compact. 1.01. What is the ratio of the Total Labor Force (in %) in Iran in 1993 to that in 1997?
Offer a very short reply. 0.89. What is the ratio of the Total Labor Force (in %) of St. Vincent and the Grenadines in 1993 to that in 1997?
Your answer should be very brief. 0.95. What is the ratio of the Total Labor Force (in %) in Iceland in 1993 to that in 1998?
Your answer should be compact. 0.99. What is the ratio of the Total Labor Force (in %) of Iran in 1993 to that in 1998?
Keep it short and to the point. 0.83. What is the ratio of the Total Labor Force (in %) in Ireland in 1993 to that in 1998?
Offer a terse response. 0.86. What is the ratio of the Total Labor Force (in %) in St. Vincent and the Grenadines in 1993 to that in 1998?
Provide a short and direct response. 0.94. What is the ratio of the Total Labor Force (in %) in Iceland in 1993 to that in 1999?
Your response must be concise. 0.97. What is the ratio of the Total Labor Force (in %) in Iran in 1993 to that in 1999?
Give a very brief answer. 0.78. What is the ratio of the Total Labor Force (in %) in Ireland in 1993 to that in 1999?
Your response must be concise. 0.82. What is the ratio of the Total Labor Force (in %) in St. Vincent and the Grenadines in 1993 to that in 1999?
Provide a short and direct response. 0.93. What is the ratio of the Total Labor Force (in %) of Iceland in 1994 to that in 1995?
Your response must be concise. 0.99. What is the ratio of the Total Labor Force (in %) in Iran in 1994 to that in 1995?
Offer a very short reply. 0.99. What is the ratio of the Total Labor Force (in %) of Ireland in 1994 to that in 1995?
Ensure brevity in your answer.  0.98. What is the ratio of the Total Labor Force (in %) in Iran in 1994 to that in 1996?
Make the answer very short. 0.97. What is the ratio of the Total Labor Force (in %) in Ireland in 1994 to that in 1996?
Offer a very short reply. 0.95. What is the ratio of the Total Labor Force (in %) in St. Vincent and the Grenadines in 1994 to that in 1996?
Your response must be concise. 0.97. What is the ratio of the Total Labor Force (in %) of Iceland in 1994 to that in 1997?
Offer a very short reply. 1.01. What is the ratio of the Total Labor Force (in %) in Iran in 1994 to that in 1997?
Give a very brief answer. 0.9. What is the ratio of the Total Labor Force (in %) of Ireland in 1994 to that in 1997?
Make the answer very short. 0.93. What is the ratio of the Total Labor Force (in %) in Iceland in 1994 to that in 1998?
Your response must be concise. 0.99. What is the ratio of the Total Labor Force (in %) in Iran in 1994 to that in 1998?
Keep it short and to the point. 0.84. What is the ratio of the Total Labor Force (in %) in Ireland in 1994 to that in 1998?
Make the answer very short. 0.88. What is the ratio of the Total Labor Force (in %) of St. Vincent and the Grenadines in 1994 to that in 1998?
Your answer should be very brief. 0.95. What is the ratio of the Total Labor Force (in %) in Iceland in 1994 to that in 1999?
Offer a terse response. 0.98. What is the ratio of the Total Labor Force (in %) of Iran in 1994 to that in 1999?
Offer a very short reply. 0.79. What is the ratio of the Total Labor Force (in %) of Ireland in 1994 to that in 1999?
Provide a short and direct response. 0.85. What is the ratio of the Total Labor Force (in %) in St. Vincent and the Grenadines in 1994 to that in 1999?
Make the answer very short. 0.94. What is the ratio of the Total Labor Force (in %) of Iceland in 1995 to that in 1996?
Keep it short and to the point. 1.01. What is the ratio of the Total Labor Force (in %) in Iran in 1995 to that in 1996?
Give a very brief answer. 0.98. What is the ratio of the Total Labor Force (in %) in Ireland in 1995 to that in 1996?
Offer a very short reply. 0.96. What is the ratio of the Total Labor Force (in %) of St. Vincent and the Grenadines in 1995 to that in 1996?
Keep it short and to the point. 0.99. What is the ratio of the Total Labor Force (in %) of Iceland in 1995 to that in 1997?
Your response must be concise. 1.02. What is the ratio of the Total Labor Force (in %) of Iran in 1995 to that in 1997?
Ensure brevity in your answer.  0.91. What is the ratio of the Total Labor Force (in %) of Ireland in 1995 to that in 1997?
Provide a succinct answer. 0.94. What is the ratio of the Total Labor Force (in %) in St. Vincent and the Grenadines in 1995 to that in 1997?
Ensure brevity in your answer.  0.98. What is the ratio of the Total Labor Force (in %) in Iceland in 1995 to that in 1998?
Your response must be concise. 1. What is the ratio of the Total Labor Force (in %) of Iran in 1995 to that in 1998?
Offer a very short reply. 0.85. What is the ratio of the Total Labor Force (in %) in Ireland in 1995 to that in 1998?
Provide a succinct answer. 0.9. What is the ratio of the Total Labor Force (in %) of St. Vincent and the Grenadines in 1995 to that in 1998?
Your answer should be very brief. 0.97. What is the ratio of the Total Labor Force (in %) in Ireland in 1995 to that in 1999?
Ensure brevity in your answer.  0.86. What is the ratio of the Total Labor Force (in %) of St. Vincent and the Grenadines in 1995 to that in 1999?
Offer a very short reply. 0.96. What is the ratio of the Total Labor Force (in %) in Iceland in 1996 to that in 1997?
Offer a very short reply. 1.01. What is the ratio of the Total Labor Force (in %) in Iran in 1996 to that in 1997?
Provide a short and direct response. 0.93. What is the ratio of the Total Labor Force (in %) in Ireland in 1996 to that in 1997?
Give a very brief answer. 0.98. What is the ratio of the Total Labor Force (in %) in St. Vincent and the Grenadines in 1996 to that in 1997?
Ensure brevity in your answer.  0.99. What is the ratio of the Total Labor Force (in %) of Iran in 1996 to that in 1998?
Make the answer very short. 0.87. What is the ratio of the Total Labor Force (in %) in Ireland in 1996 to that in 1998?
Your answer should be very brief. 0.93. What is the ratio of the Total Labor Force (in %) in St. Vincent and the Grenadines in 1996 to that in 1998?
Give a very brief answer. 0.98. What is the ratio of the Total Labor Force (in %) of Iceland in 1996 to that in 1999?
Keep it short and to the point. 0.98. What is the ratio of the Total Labor Force (in %) in Iran in 1996 to that in 1999?
Your answer should be very brief. 0.82. What is the ratio of the Total Labor Force (in %) in Ireland in 1996 to that in 1999?
Provide a short and direct response. 0.89. What is the ratio of the Total Labor Force (in %) in St. Vincent and the Grenadines in 1996 to that in 1999?
Offer a terse response. 0.97. What is the ratio of the Total Labor Force (in %) of Iceland in 1997 to that in 1998?
Offer a very short reply. 0.98. What is the ratio of the Total Labor Force (in %) in Iran in 1997 to that in 1998?
Ensure brevity in your answer.  0.93. What is the ratio of the Total Labor Force (in %) in Ireland in 1997 to that in 1998?
Provide a succinct answer. 0.95. What is the ratio of the Total Labor Force (in %) of St. Vincent and the Grenadines in 1997 to that in 1998?
Your answer should be very brief. 0.99. What is the ratio of the Total Labor Force (in %) of Iceland in 1997 to that in 1999?
Your answer should be very brief. 0.97. What is the ratio of the Total Labor Force (in %) of Iran in 1997 to that in 1999?
Make the answer very short. 0.88. What is the ratio of the Total Labor Force (in %) of St. Vincent and the Grenadines in 1997 to that in 1999?
Offer a very short reply. 0.98. What is the ratio of the Total Labor Force (in %) of Iceland in 1998 to that in 1999?
Your response must be concise. 0.99. What is the ratio of the Total Labor Force (in %) in Iran in 1998 to that in 1999?
Offer a terse response. 0.94. What is the ratio of the Total Labor Force (in %) in Ireland in 1998 to that in 1999?
Offer a terse response. 0.96. What is the ratio of the Total Labor Force (in %) of St. Vincent and the Grenadines in 1998 to that in 1999?
Your response must be concise. 0.99. What is the difference between the highest and the second highest Total Labor Force (in %) of Iran?
Your answer should be very brief. 0.8. What is the difference between the highest and the second highest Total Labor Force (in %) of St. Vincent and the Grenadines?
Provide a short and direct response. 0.6. What is the difference between the highest and the lowest Total Labor Force (in %) in Iceland?
Your answer should be very brief. 2.3. What is the difference between the highest and the lowest Total Labor Force (in %) in Iran?
Provide a short and direct response. 3. What is the difference between the highest and the lowest Total Labor Force (in %) in Ireland?
Your response must be concise. 9.7. 